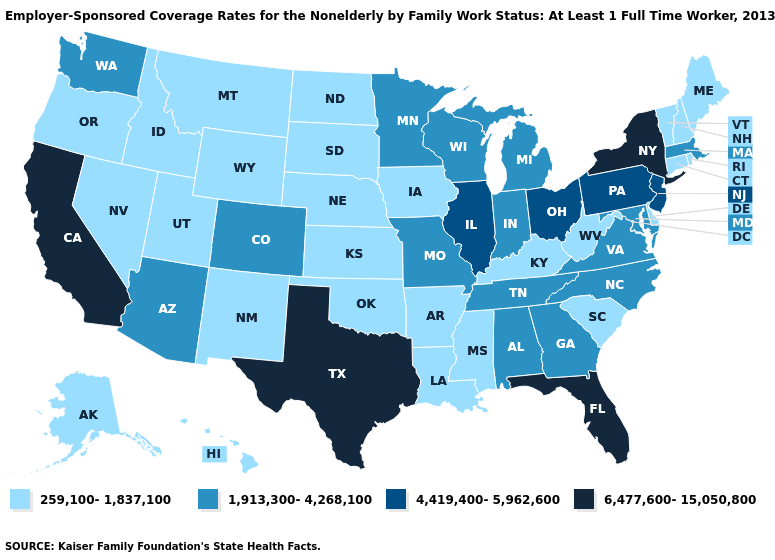Does Ohio have the highest value in the MidWest?
Keep it brief. Yes. What is the value of North Carolina?
Be succinct. 1,913,300-4,268,100. What is the value of Iowa?
Write a very short answer. 259,100-1,837,100. How many symbols are there in the legend?
Quick response, please. 4. What is the lowest value in states that border Wisconsin?
Give a very brief answer. 259,100-1,837,100. Does Delaware have the highest value in the South?
Give a very brief answer. No. What is the value of Nebraska?
Short answer required. 259,100-1,837,100. What is the lowest value in states that border Arkansas?
Be succinct. 259,100-1,837,100. What is the value of Alaska?
Answer briefly. 259,100-1,837,100. Does the first symbol in the legend represent the smallest category?
Keep it brief. Yes. Does the map have missing data?
Quick response, please. No. What is the value of Michigan?
Answer briefly. 1,913,300-4,268,100. What is the value of South Carolina?
Give a very brief answer. 259,100-1,837,100. What is the highest value in the USA?
Keep it brief. 6,477,600-15,050,800. Name the states that have a value in the range 259,100-1,837,100?
Concise answer only. Alaska, Arkansas, Connecticut, Delaware, Hawaii, Idaho, Iowa, Kansas, Kentucky, Louisiana, Maine, Mississippi, Montana, Nebraska, Nevada, New Hampshire, New Mexico, North Dakota, Oklahoma, Oregon, Rhode Island, South Carolina, South Dakota, Utah, Vermont, West Virginia, Wyoming. 